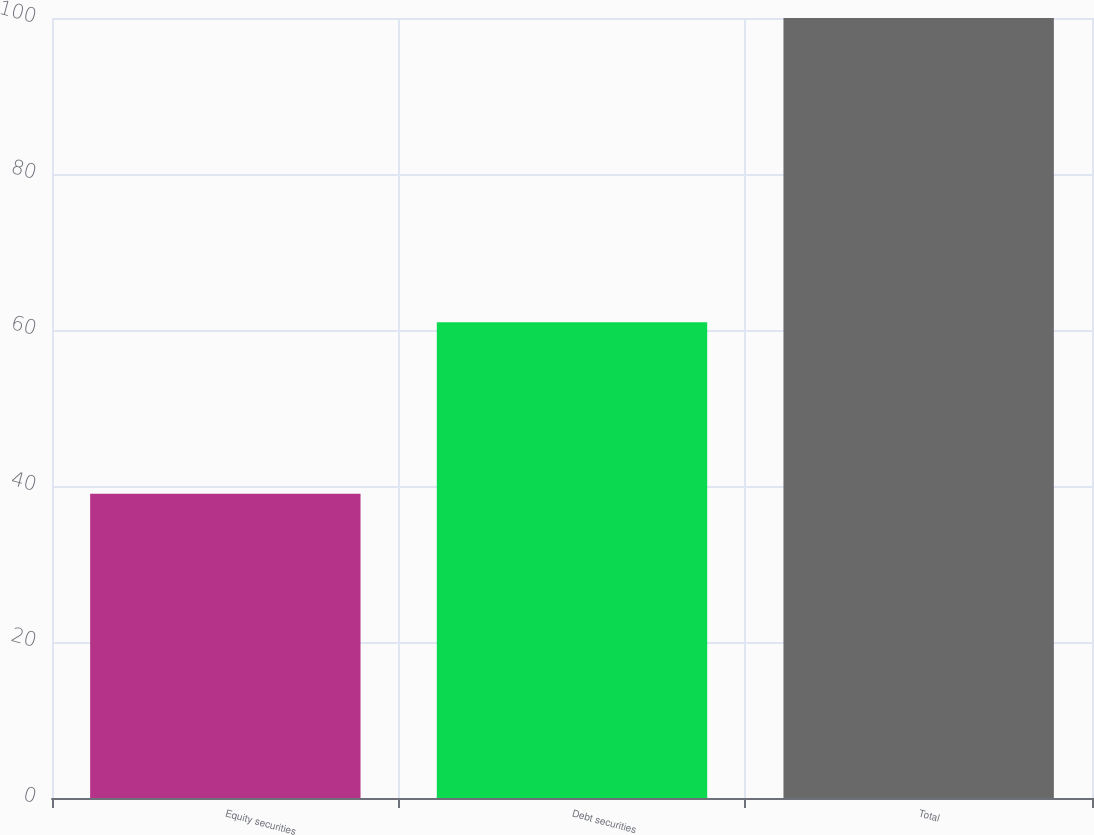<chart> <loc_0><loc_0><loc_500><loc_500><bar_chart><fcel>Equity securities<fcel>Debt securities<fcel>Total<nl><fcel>39<fcel>61<fcel>100<nl></chart> 